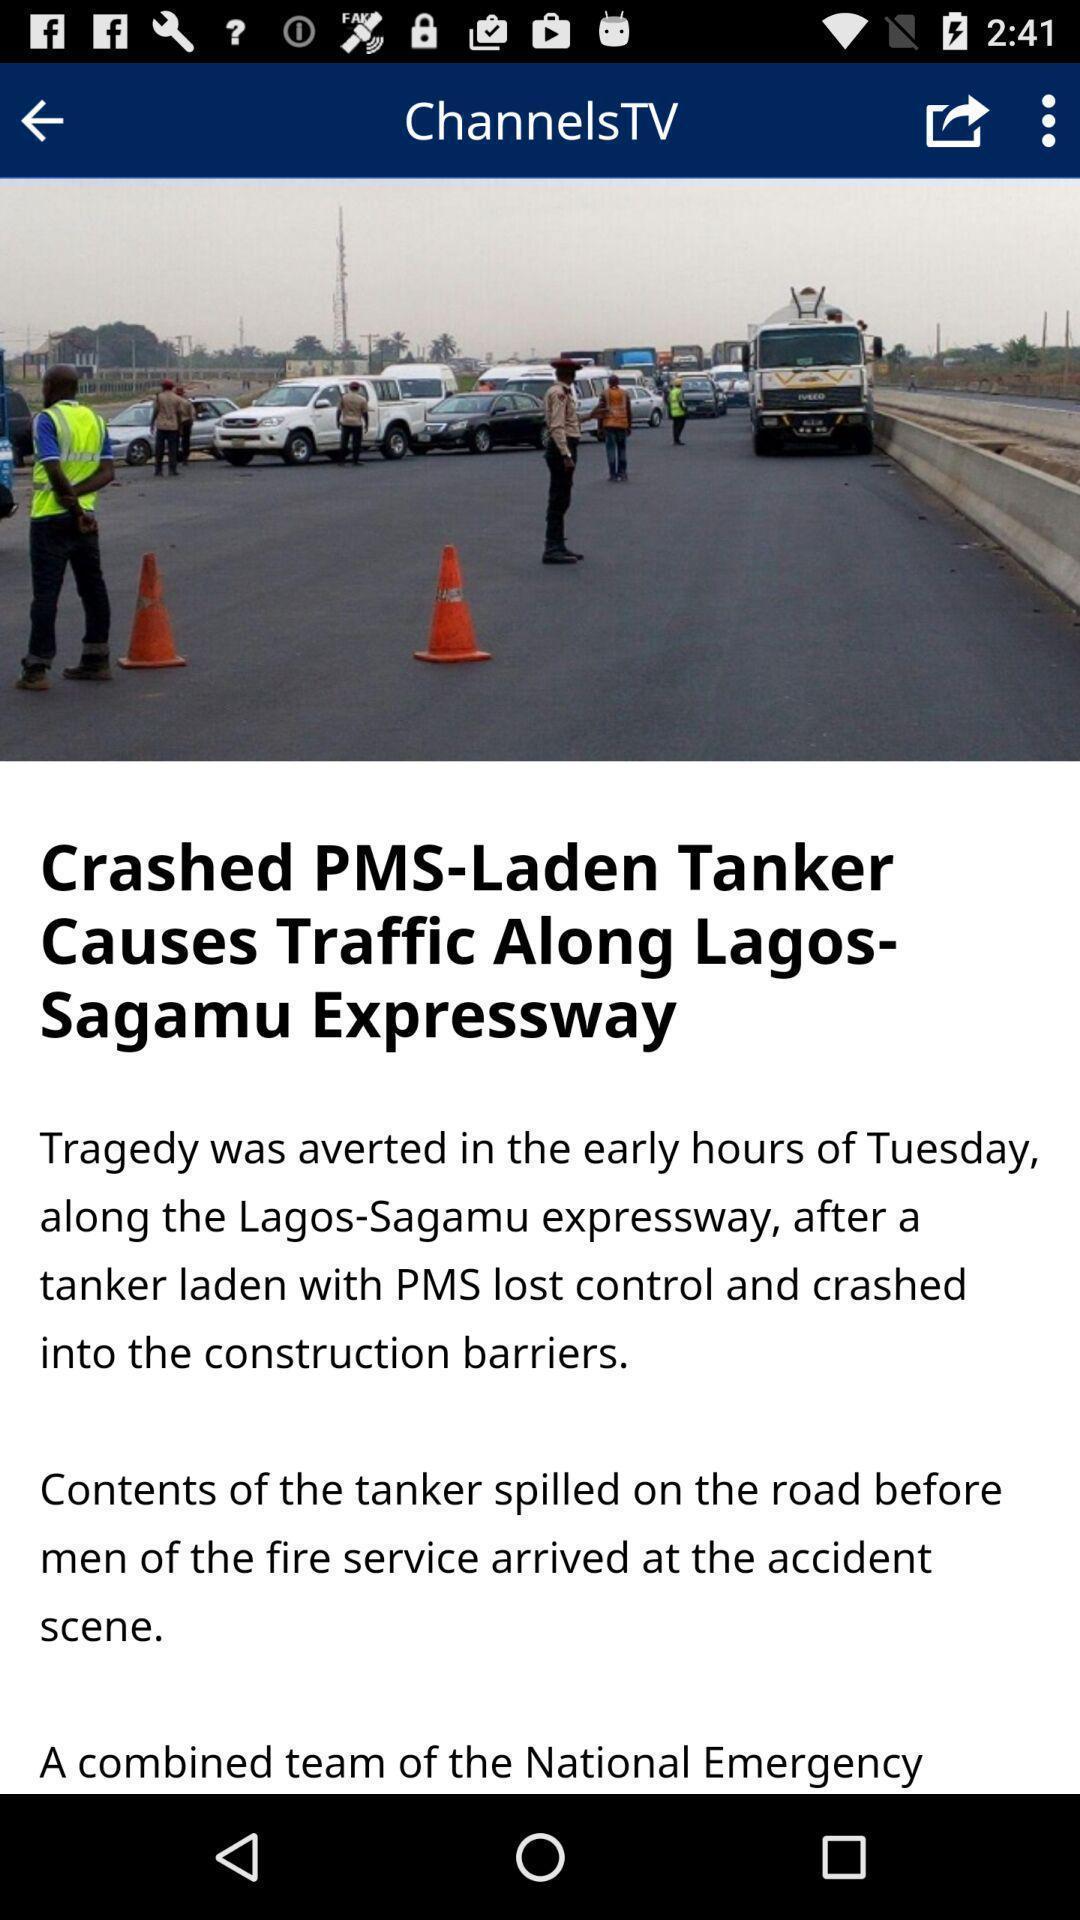What details can you identify in this image? Screen displaying news. 